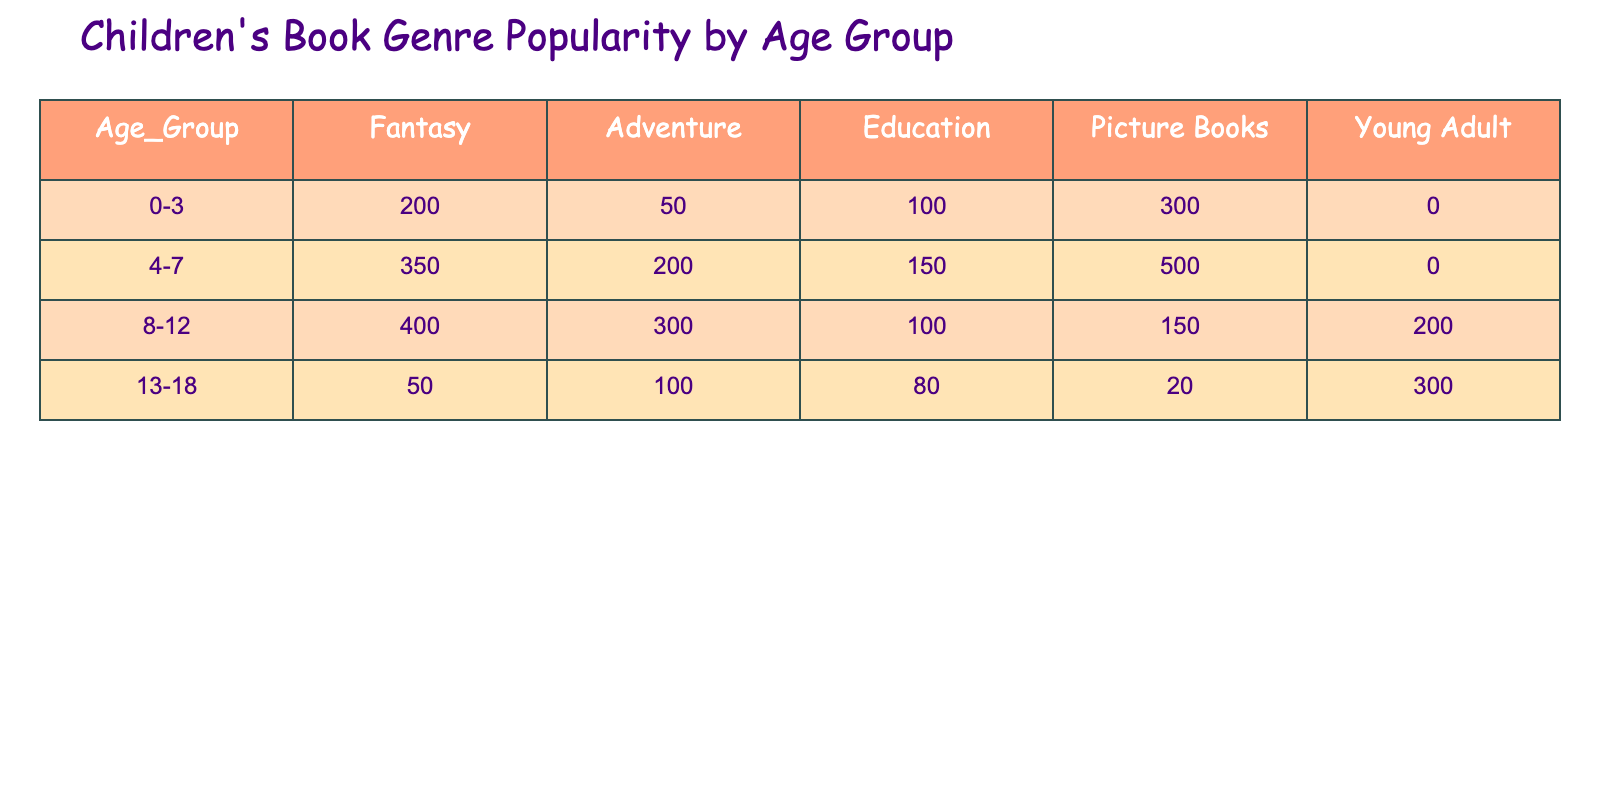What is the highest popular genre for the age group 4-7? Looking at the row for the age group 4-7, we can see the values are: Fantasy 350, Adventure 200, Education 150, Picture Books 500, and Young Adult 0. The highest value is for Picture Books at 500.
Answer: Picture Books Which genre has the lowest popularity among 0-3 year olds? In the age group 0-3, the genres are as follows: Fantasy 200, Adventure 50, Education 100, Picture Books 300, and Young Adult 0. The lowest value is for Young Adult at 0.
Answer: Young Adult How many total books in the Adventure genre are there across all age groups? To find the total Adventure books, we sum the values from each age group: 50 (0-3) + 200 (4-7) + 300 (8-12) + 100 (13-18) = 650.
Answer: 650 Is the popularity of the Education genre consistent across all age groups? Looking at the Education genre values: 100 (0-3), 150 (4-7), 100 (8-12), and 80 (13-18), we can see there is a variation, with totals 100, 150, and then a drop to 80, indicating inconsistency.
Answer: No What is the combined popularity of Fantasy and Adventure for the age group 8-12? The values for Fantasy and Adventure in the age group 8-12 are 400 and 300, respectively. Adding these together gives us: 400 + 300 = 700.
Answer: 700 Which age group has the highest total number of books across all genres? To find the highest total, we calculate the total for each age group: 0-3: 200+50+100+300+0 = 650, 4-7: 350+200+150+500+0 = 1200, 8-12: 400+300+100+150+200 = 1150, and 13-18: 50+100+80+20+300 = 550. The highest total is for age group 4-7 at 1200.
Answer: 4-7 What is the difference in popularity between the Picture Books genre and the Young Adult genre for the 8-12 age group? The values for the 8-12 age group are 150 for Picture Books and 200 for Young Adult. Calculating the difference gives us: 200 - 150 = 50.
Answer: 50 Which genre is the most popular among the 13-18 age group? In the 13-18 age group, the values are: Fantasy 50, Adventure 100, Education 80, Picture Books 20, and Young Adult 300. The highest value is for Young Adult at 300.
Answer: Young Adult 